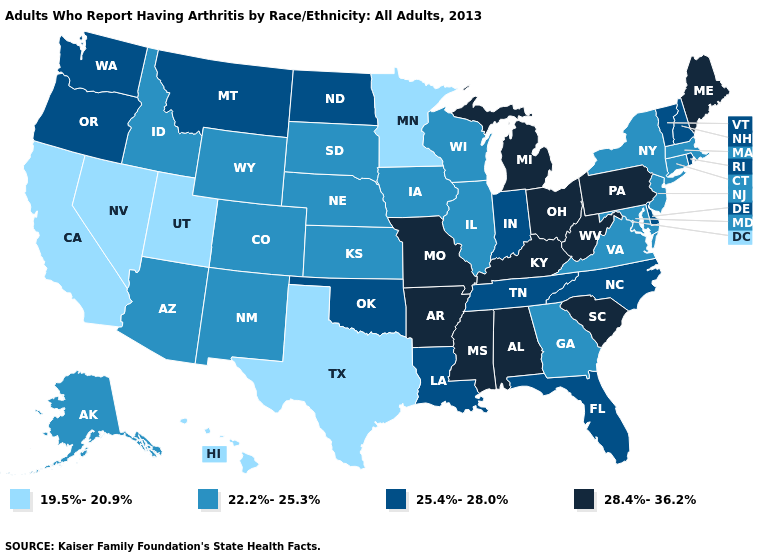Among the states that border New Hampshire , does Massachusetts have the lowest value?
Answer briefly. Yes. Which states have the lowest value in the South?
Give a very brief answer. Texas. Which states have the highest value in the USA?
Quick response, please. Alabama, Arkansas, Kentucky, Maine, Michigan, Mississippi, Missouri, Ohio, Pennsylvania, South Carolina, West Virginia. What is the highest value in the MidWest ?
Concise answer only. 28.4%-36.2%. What is the highest value in the Northeast ?
Answer briefly. 28.4%-36.2%. What is the value of Mississippi?
Short answer required. 28.4%-36.2%. Name the states that have a value in the range 25.4%-28.0%?
Write a very short answer. Delaware, Florida, Indiana, Louisiana, Montana, New Hampshire, North Carolina, North Dakota, Oklahoma, Oregon, Rhode Island, Tennessee, Vermont, Washington. What is the lowest value in the West?
Concise answer only. 19.5%-20.9%. Does Oregon have a higher value than Nevada?
Answer briefly. Yes. Among the states that border Michigan , does Wisconsin have the lowest value?
Be succinct. Yes. What is the value of South Dakota?
Keep it brief. 22.2%-25.3%. Name the states that have a value in the range 28.4%-36.2%?
Give a very brief answer. Alabama, Arkansas, Kentucky, Maine, Michigan, Mississippi, Missouri, Ohio, Pennsylvania, South Carolina, West Virginia. What is the highest value in the MidWest ?
Be succinct. 28.4%-36.2%. What is the highest value in states that border Arizona?
Concise answer only. 22.2%-25.3%. Among the states that border Missouri , which have the highest value?
Answer briefly. Arkansas, Kentucky. 